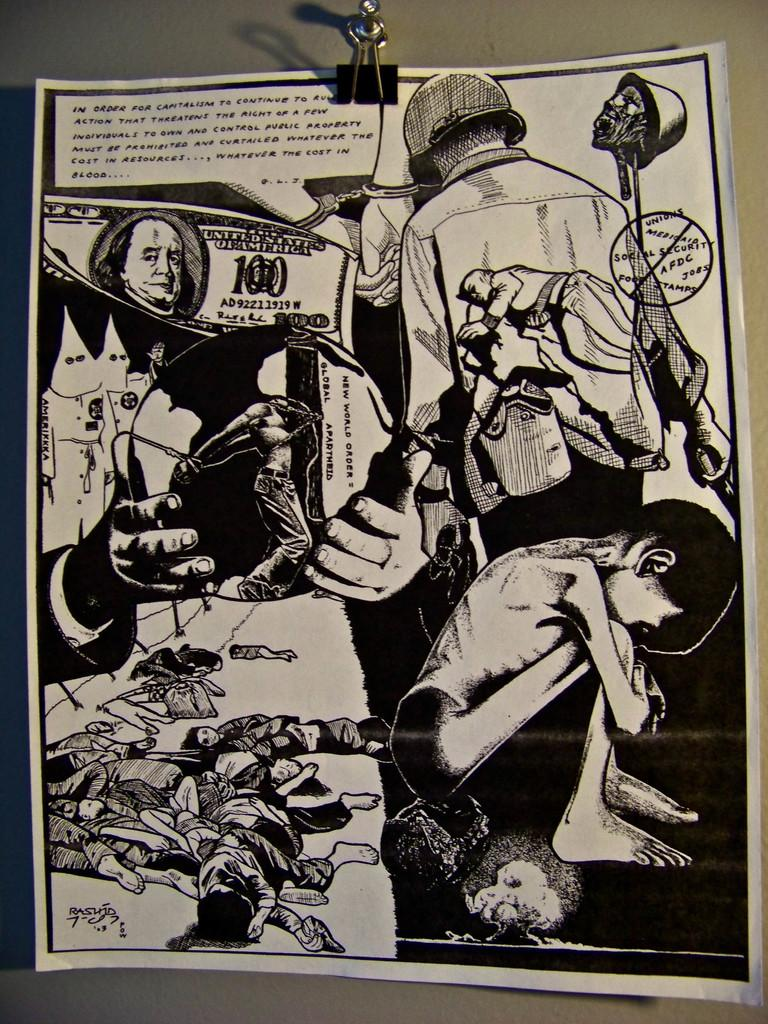<image>
Render a clear and concise summary of the photo. A paper clipped to a wall that says "new world order = global apartheid" 